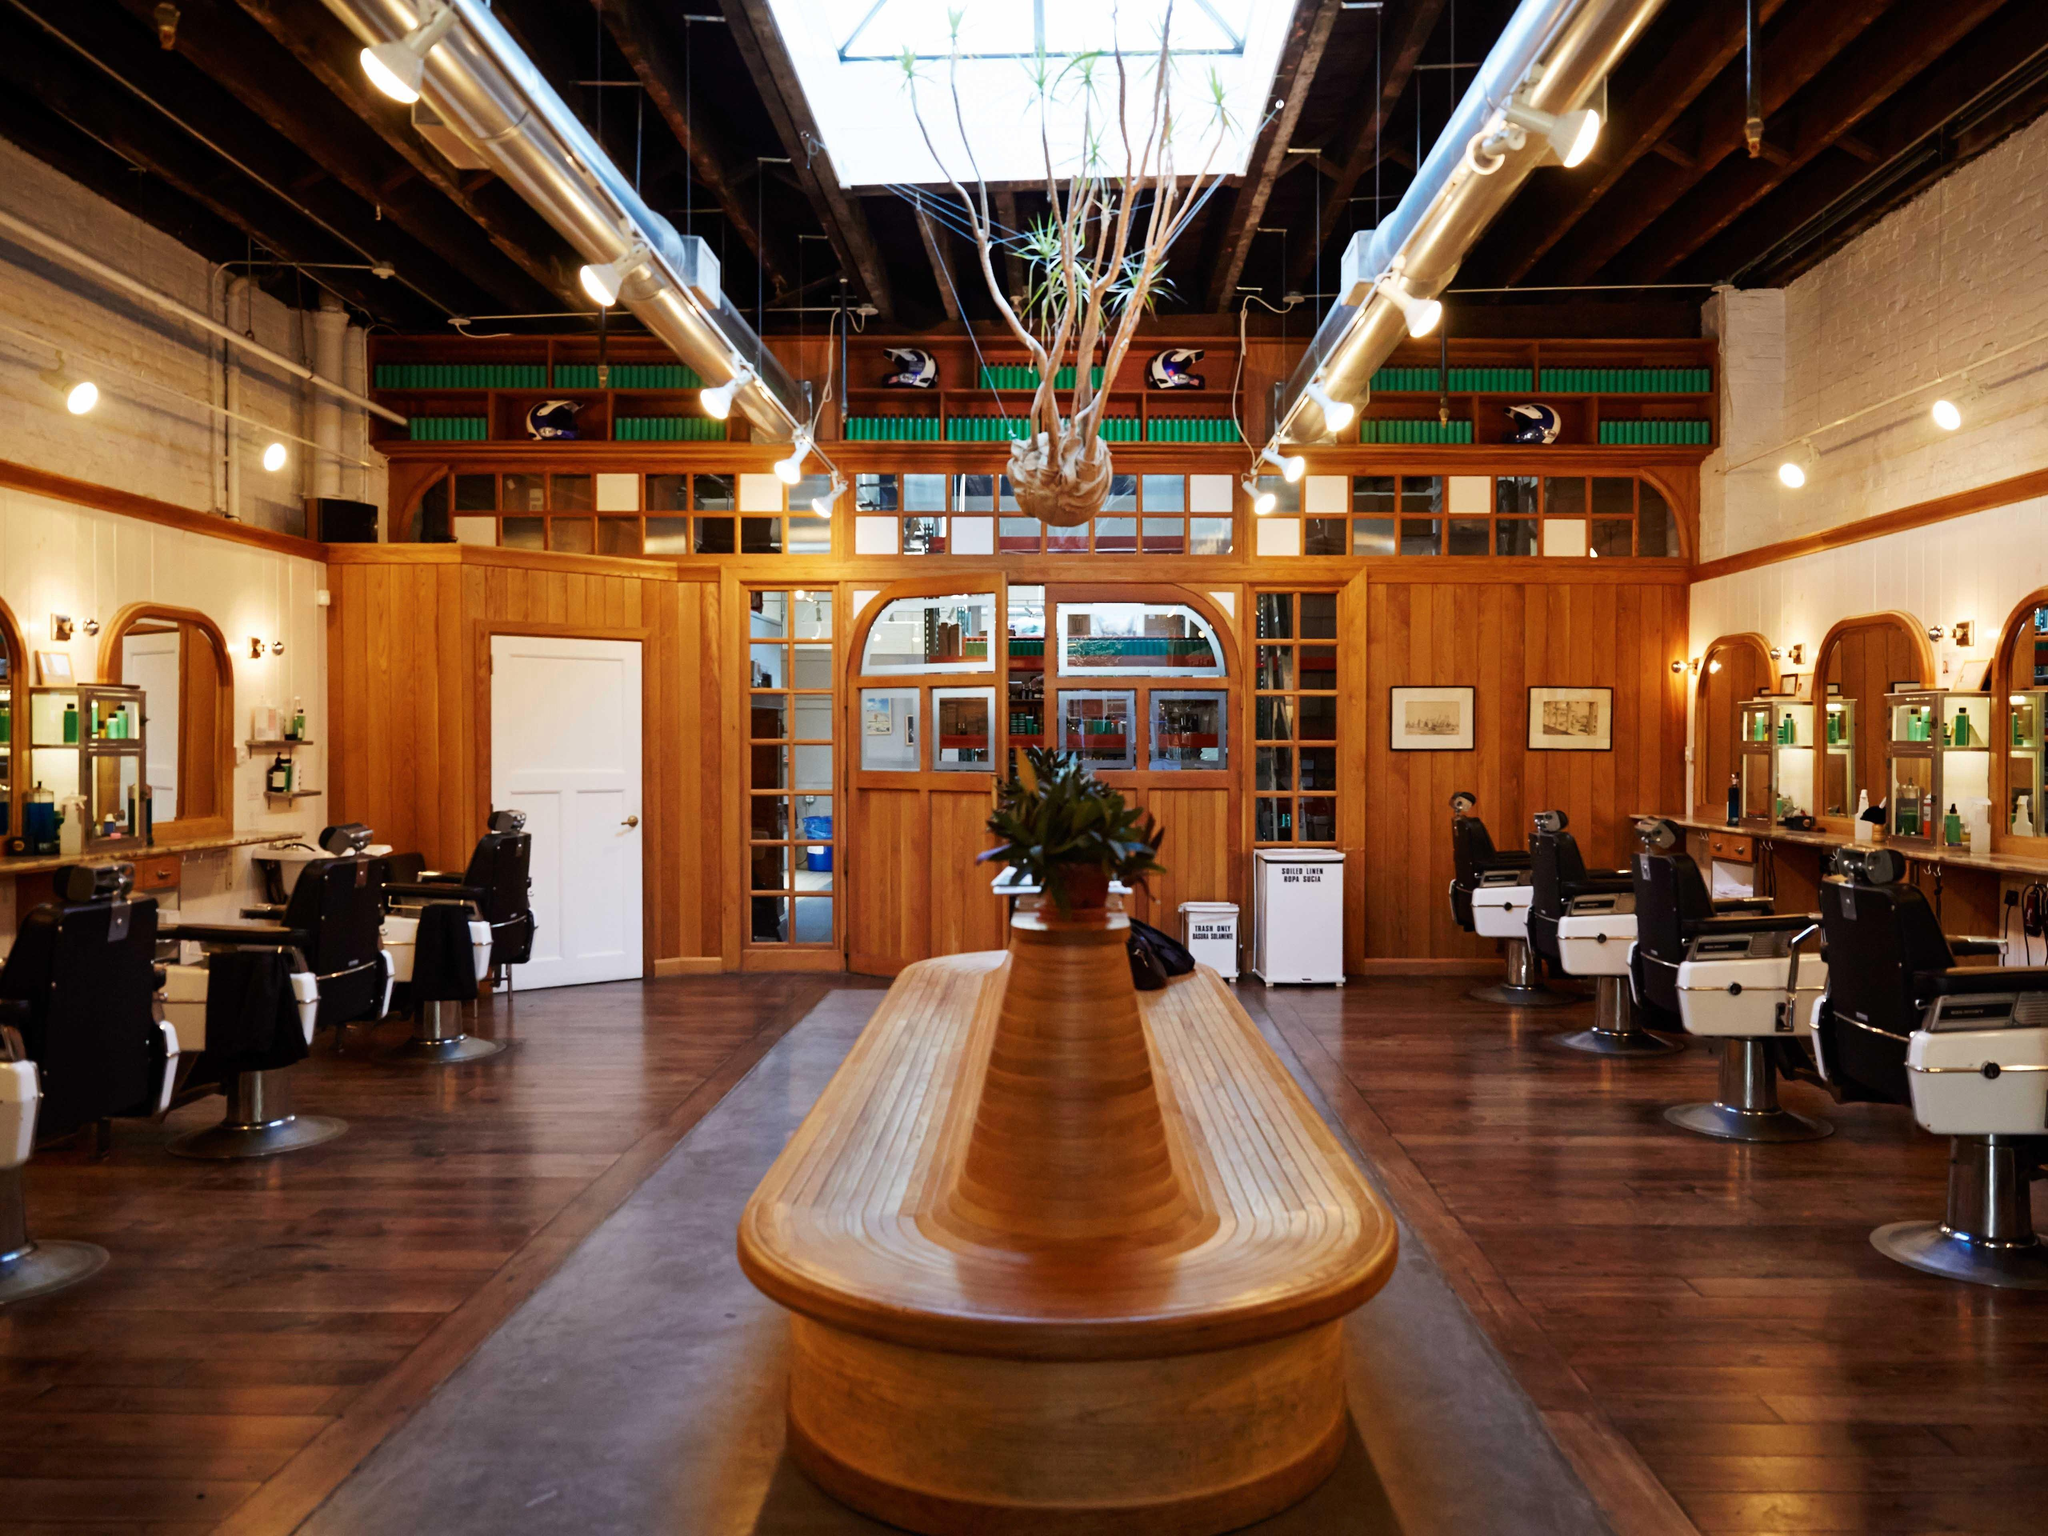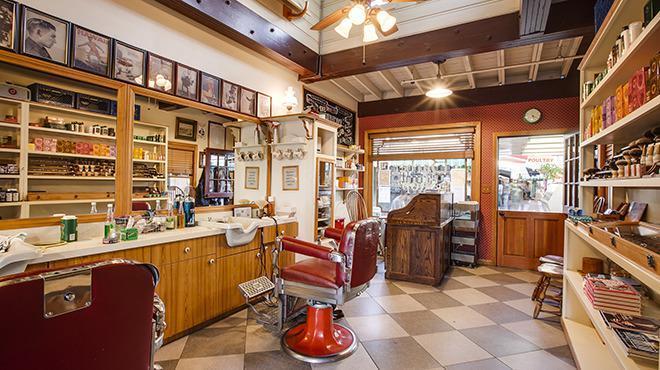The first image is the image on the left, the second image is the image on the right. Evaluate the accuracy of this statement regarding the images: "One of the images contains a bench for seating in the middle of the room". Is it true? Answer yes or no. Yes. The first image is the image on the left, the second image is the image on the right. Examine the images to the left and right. Is the description "A long oblong counter with a peaked top is in the center of the salon, flanked by barber chairs, in one image." accurate? Answer yes or no. Yes. 